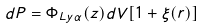Convert formula to latex. <formula><loc_0><loc_0><loc_500><loc_500>d P = \Phi _ { L y \alpha } ( z ) d V [ 1 + \xi ( r ) ]</formula> 